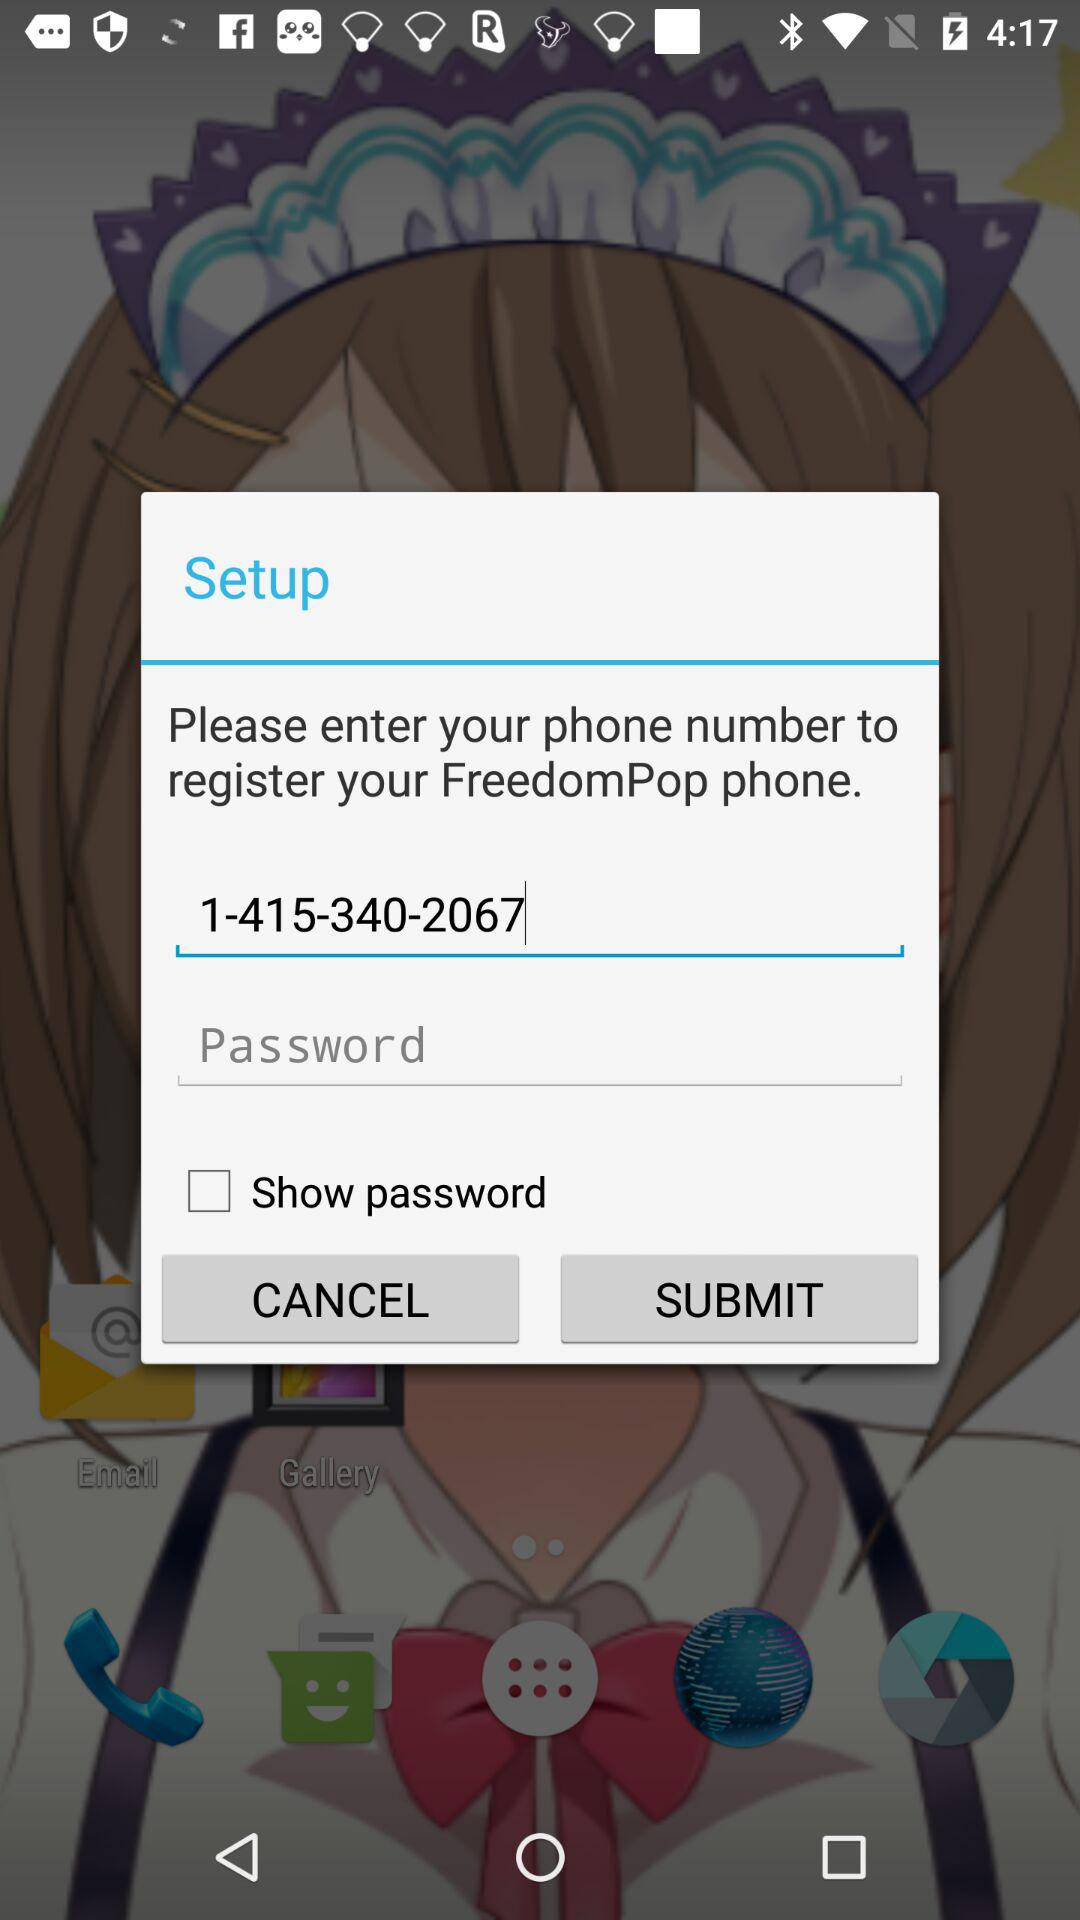What is the phone number to register the "FreedomPop" phone? The phone number is 1-415-340-2067. 